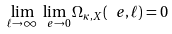Convert formula to latex. <formula><loc_0><loc_0><loc_500><loc_500>\lim _ { \ell \to \infty } \lim _ { \ e \to 0 } \Omega _ { \kappa , X } ( \ e , \ell ) = 0</formula> 